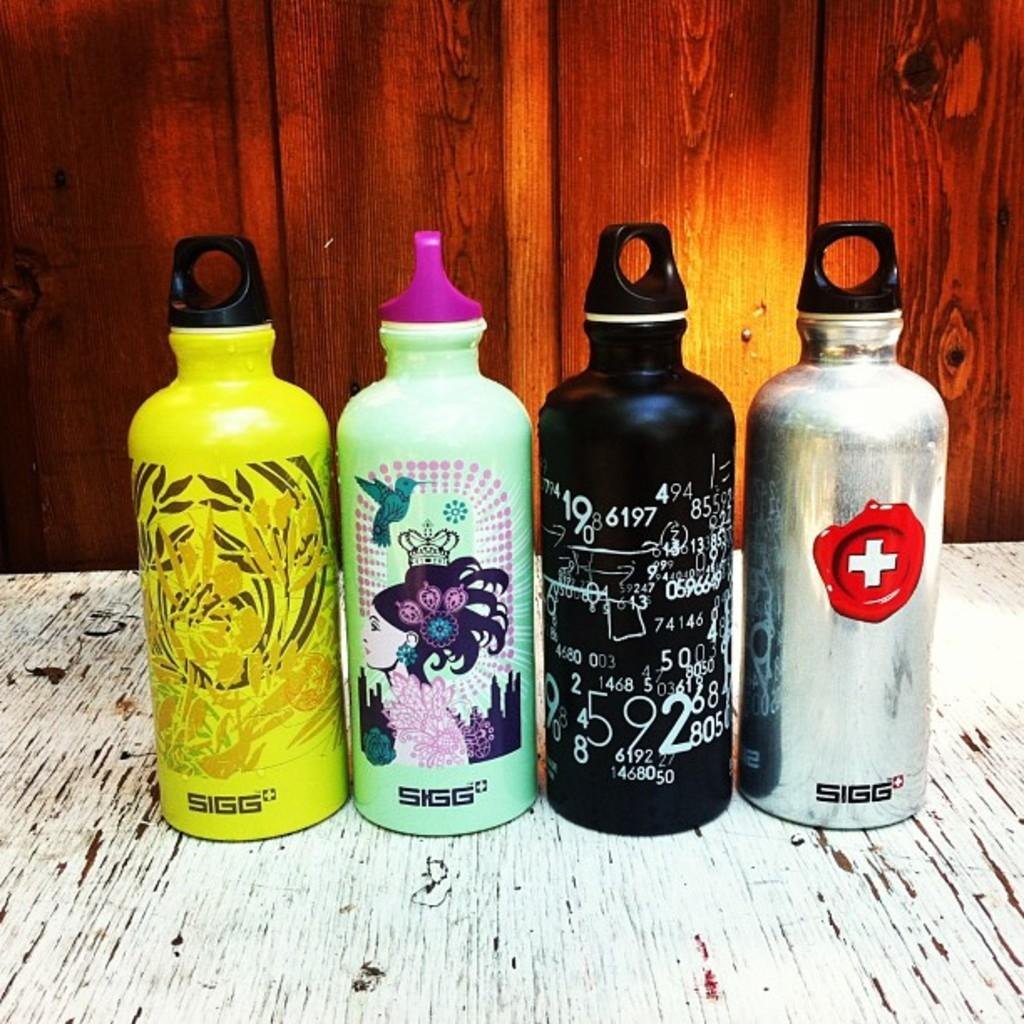<image>
Share a concise interpretation of the image provided. Sigg growlers that have different designs on each growler 